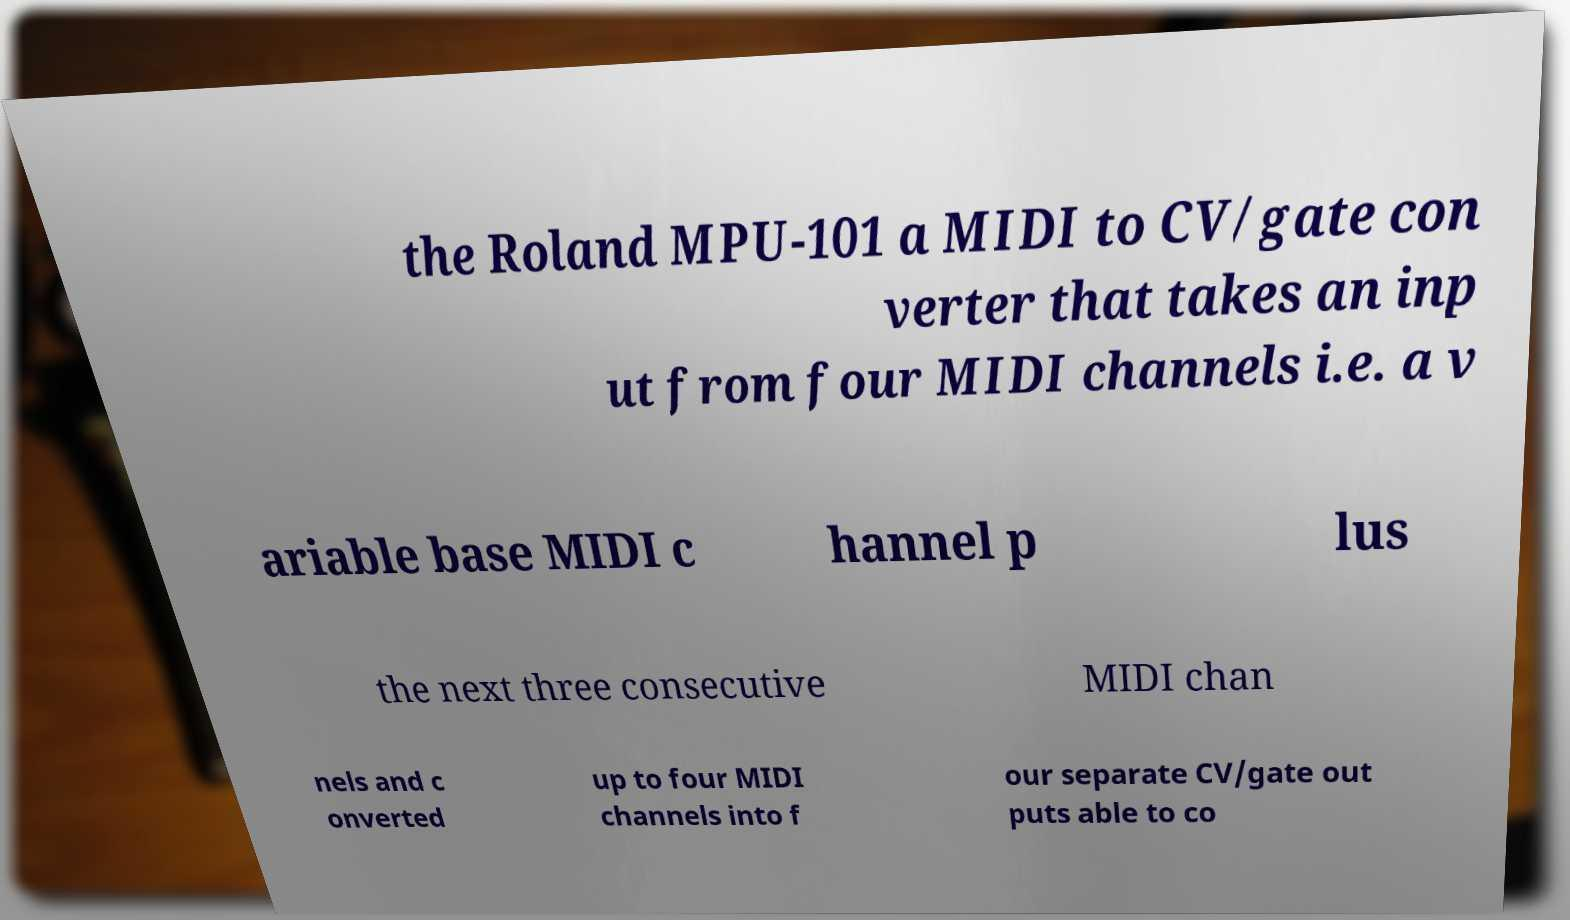Could you extract and type out the text from this image? the Roland MPU-101 a MIDI to CV/gate con verter that takes an inp ut from four MIDI channels i.e. a v ariable base MIDI c hannel p lus the next three consecutive MIDI chan nels and c onverted up to four MIDI channels into f our separate CV/gate out puts able to co 